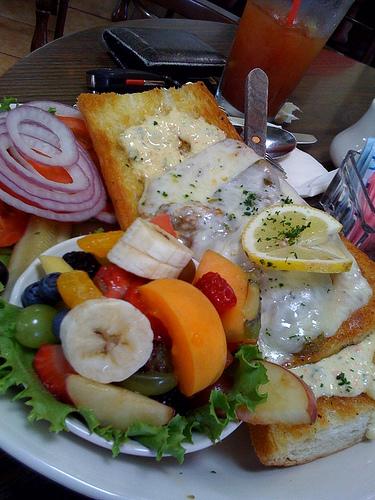What kind of fruits are there?
Write a very short answer. Banana, apple strawberry. Is this garlic bread?
Concise answer only. Yes. Is the food eaten?
Keep it brief. No. What kind of fruit is on the plate?
Keep it brief. Lemon strawberry banana grapes blueberries. 